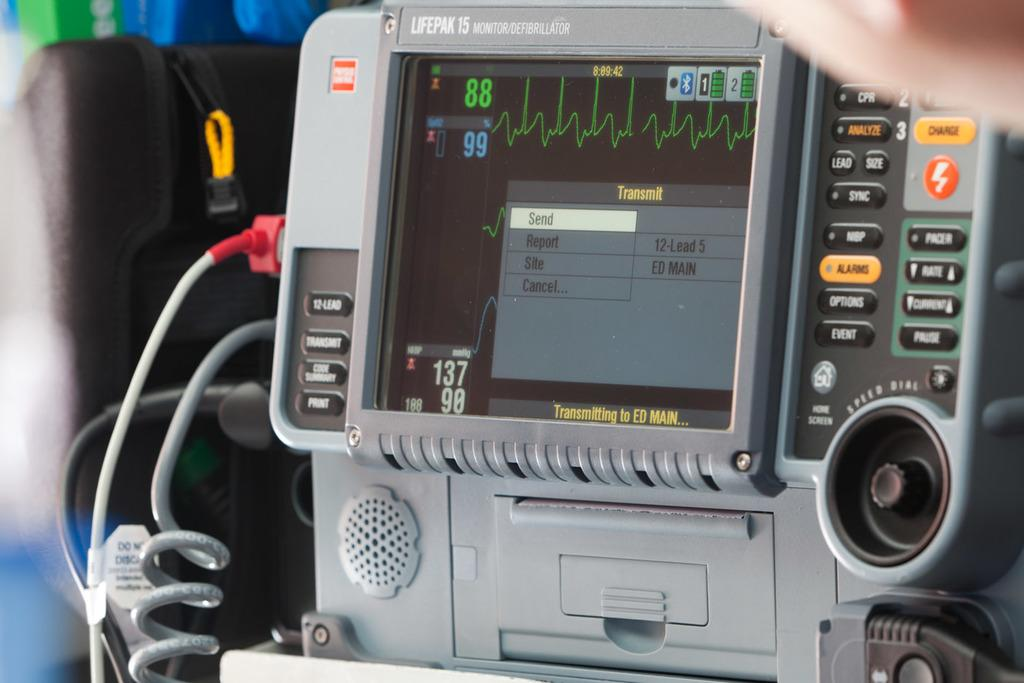What type of machine is visible in the image? There is a heartbeat monitoring machine in the image. Can you describe any additional features of the machine? There are cables on the left side of the image. Can you tell me how many dogs are sitting next to the heartbeat monitoring machine in the image? There are no dogs present in the image. What type of appliance is connected to the heartbeat monitoring machine in the image? The image does not show any appliances connected to the heartbeat monitoring machine. 